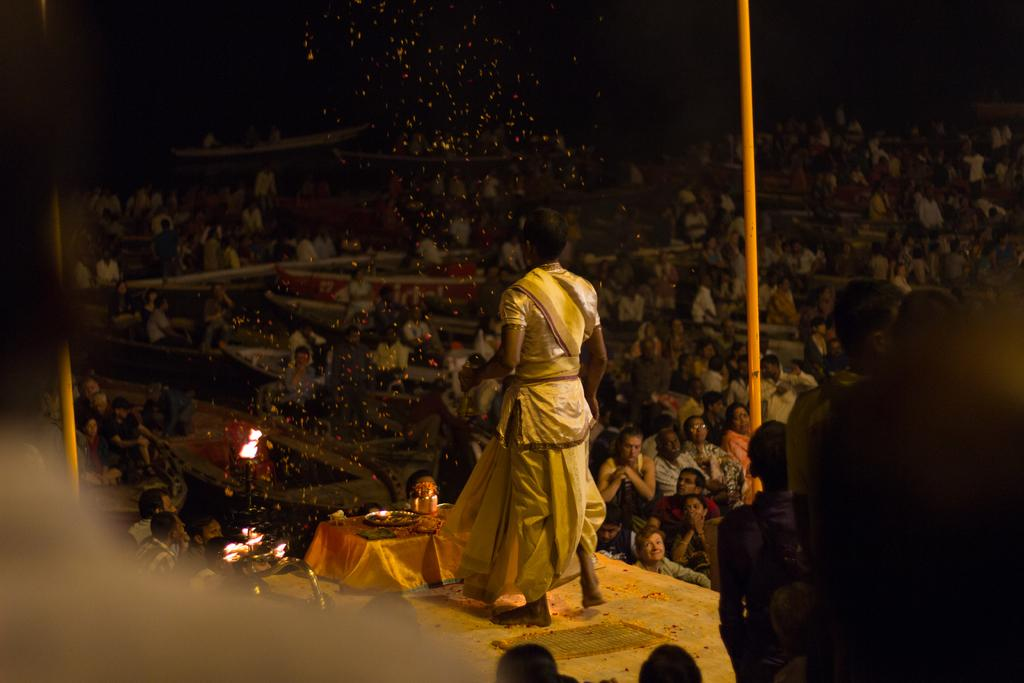Who or what can be seen in the image? There are people in the image. What else is present in the image besides people? There are lights and plates in the image. Can you describe the attire of one of the individuals in the image? A man is wearing a white color dress. How would you describe the overall lighting in the image? The image is slightly dark. What is the price of the argument happening in the image? There is no argument present in the image, so it is not possible to determine a price. 